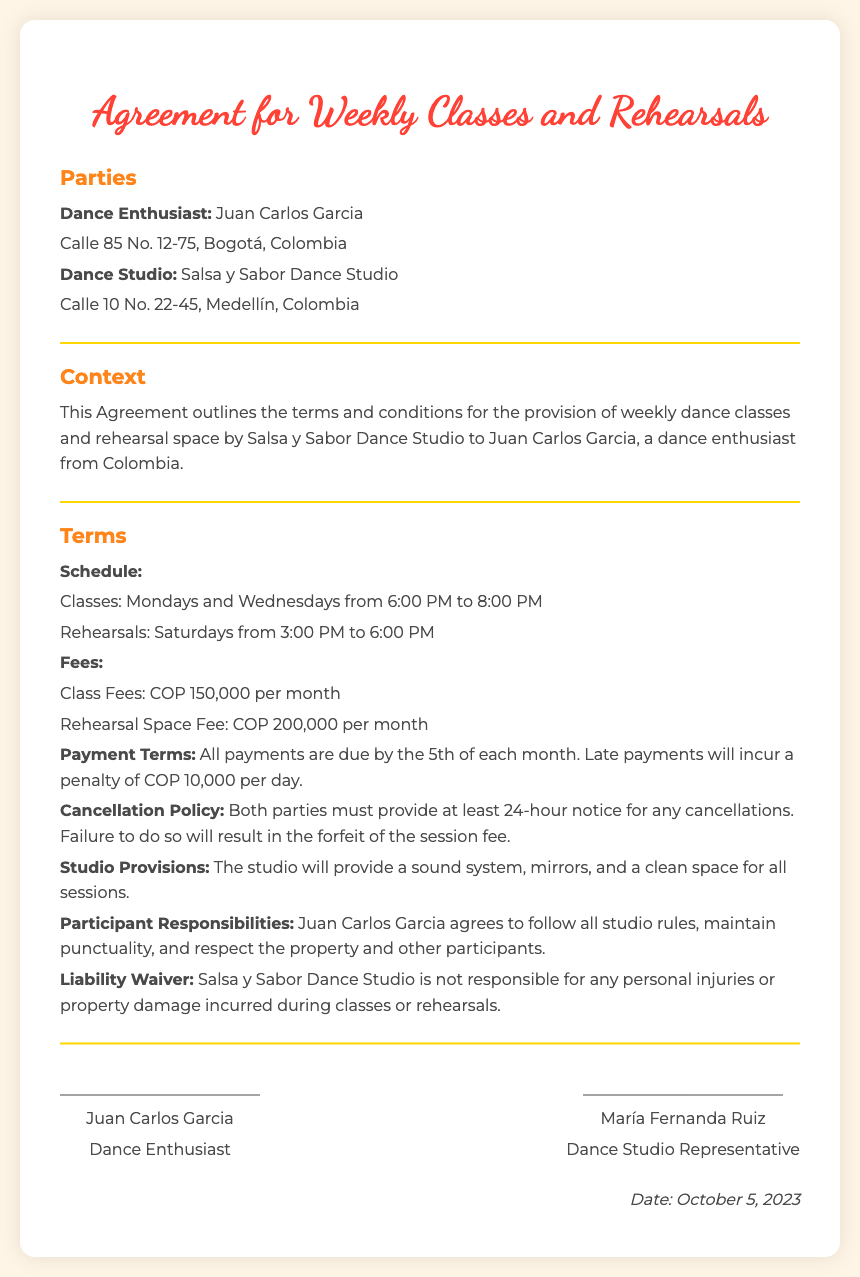What is the name of the dance studio? The dance studio is named Salsa y Sabor Dance Studio.
Answer: Salsa y Sabor Dance Studio Who signed as the dance studio representative? The representative of the dance studio is María Fernanda Ruiz.
Answer: María Fernanda Ruiz What is the monthly fee for classes? The document states the class fees are COP 150,000 per month.
Answer: COP 150,000 When are the rehearsals scheduled? The rehearsals are scheduled for Saturdays from 3:00 PM to 6:00 PM.
Answer: Saturdays from 3:00 PM to 6:00 PM What is the late payment penalty? The penalty for late payments is COP 10,000 per day.
Answer: COP 10,000 What address is listed for Juan Carlos Garcia? The address for Juan Carlos Garcia is Calle 85 No. 12-75, Bogotá, Colombia.
Answer: Calle 85 No. 12-75, Bogotá, Colombia What is the cancellation notice period required? The required cancellation notice period is at least 24 hours.
Answer: 24 hours What type of spaces and equipment does the studio provide? The studio provides a sound system, mirrors, and a clean space for sessions.
Answer: Sound system, mirrors, clean space What is the signing date of the agreement? The agreement is dated October 5, 2023.
Answer: October 5, 2023 